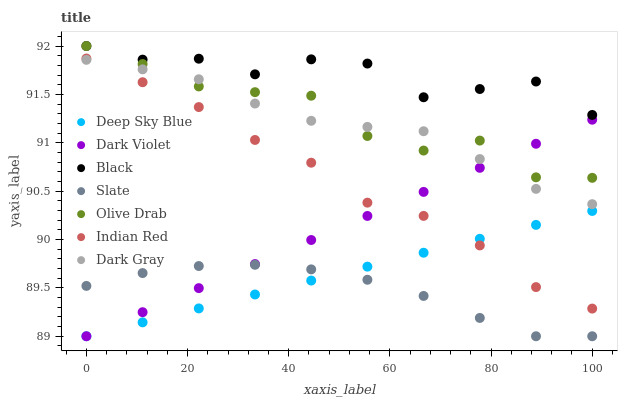Does Slate have the minimum area under the curve?
Answer yes or no. Yes. Does Black have the maximum area under the curve?
Answer yes or no. Yes. Does Dark Violet have the minimum area under the curve?
Answer yes or no. No. Does Dark Violet have the maximum area under the curve?
Answer yes or no. No. Is Dark Violet the smoothest?
Answer yes or no. Yes. Is Black the roughest?
Answer yes or no. Yes. Is Slate the smoothest?
Answer yes or no. No. Is Slate the roughest?
Answer yes or no. No. Does Deep Sky Blue have the lowest value?
Answer yes or no. Yes. Does Dark Gray have the lowest value?
Answer yes or no. No. Does Olive Drab have the highest value?
Answer yes or no. Yes. Does Dark Violet have the highest value?
Answer yes or no. No. Is Deep Sky Blue less than Dark Gray?
Answer yes or no. Yes. Is Black greater than Dark Violet?
Answer yes or no. Yes. Does Olive Drab intersect Black?
Answer yes or no. Yes. Is Olive Drab less than Black?
Answer yes or no. No. Is Olive Drab greater than Black?
Answer yes or no. No. Does Deep Sky Blue intersect Dark Gray?
Answer yes or no. No. 